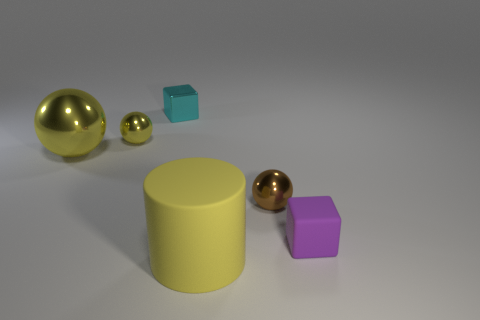Is the color of the cube on the left side of the purple cube the same as the sphere behind the big shiny ball?
Your response must be concise. No. What is the shape of the matte thing that is behind the big yellow thing that is on the right side of the cyan cube?
Your answer should be compact. Cube. How many other objects are the same color as the tiny rubber thing?
Your answer should be compact. 0. Are the big yellow ball behind the large yellow matte cylinder and the tiny block that is on the left side of the big yellow matte thing made of the same material?
Your answer should be compact. Yes. What is the size of the rubber object to the left of the purple block?
Ensure brevity in your answer.  Large. There is another small thing that is the same shape as the tiny yellow thing; what is it made of?
Your answer should be very brief. Metal. Are there any other things that have the same size as the brown metal thing?
Keep it short and to the point. Yes. There is a big thing that is behind the small brown shiny sphere; what shape is it?
Offer a terse response. Sphere. How many small yellow objects have the same shape as the big matte object?
Offer a terse response. 0. Are there an equal number of tiny yellow metallic balls that are to the left of the big shiny thing and big yellow shiny things that are on the right side of the brown object?
Your response must be concise. Yes. 